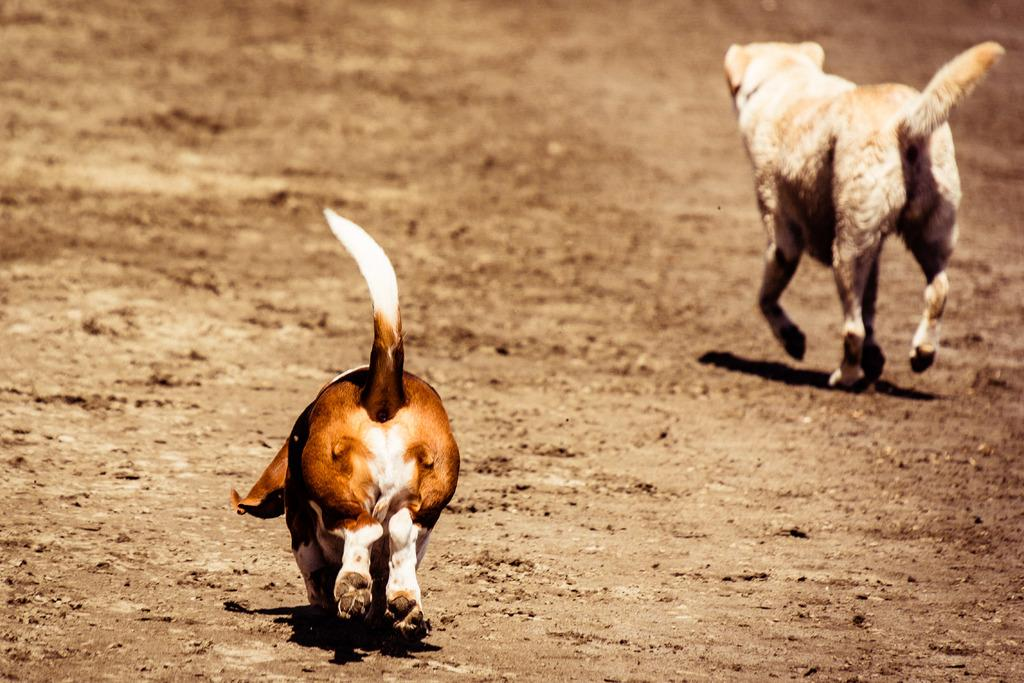How many dogs are present in the image? There are two dogs in the picture. What are the dogs doing in the image? The dogs are running on the ground. What type of cheese is being used to create a basin for the dogs to play in the image? There is no cheese or basin present in the image; it features two dogs running on the ground. What drug is being administered to the dogs in the image? There is no drug or indication of any medical treatment in the image; it features two dogs running on the ground. 